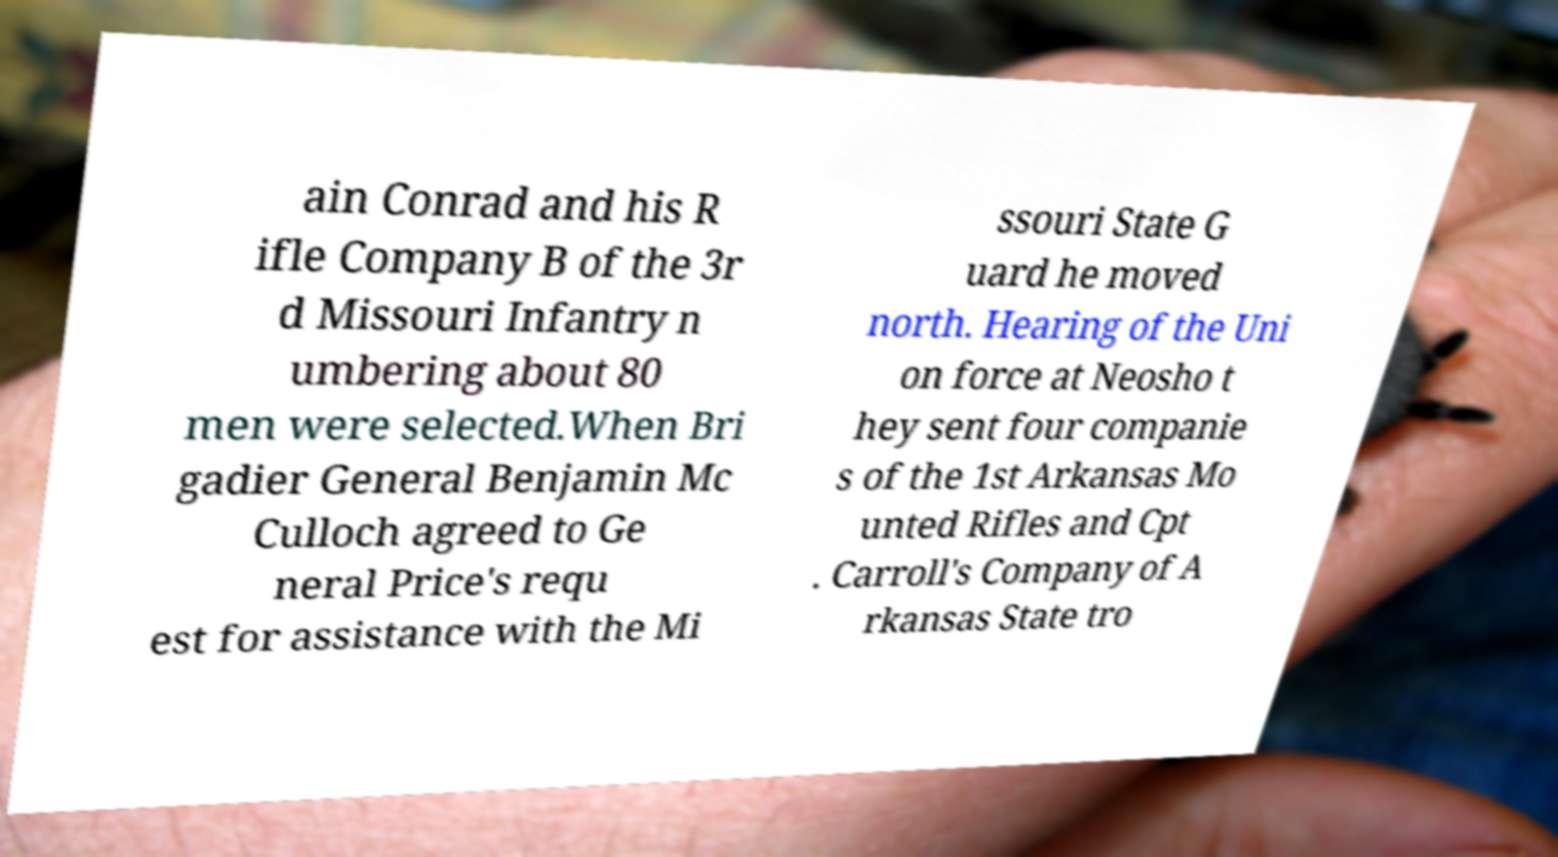Please read and relay the text visible in this image. What does it say? ain Conrad and his R ifle Company B of the 3r d Missouri Infantry n umbering about 80 men were selected.When Bri gadier General Benjamin Mc Culloch agreed to Ge neral Price's requ est for assistance with the Mi ssouri State G uard he moved north. Hearing of the Uni on force at Neosho t hey sent four companie s of the 1st Arkansas Mo unted Rifles and Cpt . Carroll's Company of A rkansas State tro 